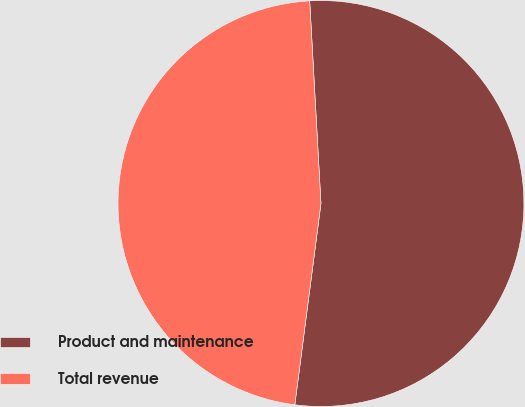Convert chart. <chart><loc_0><loc_0><loc_500><loc_500><pie_chart><fcel>Product and maintenance<fcel>Total revenue<nl><fcel>52.94%<fcel>47.06%<nl></chart> 